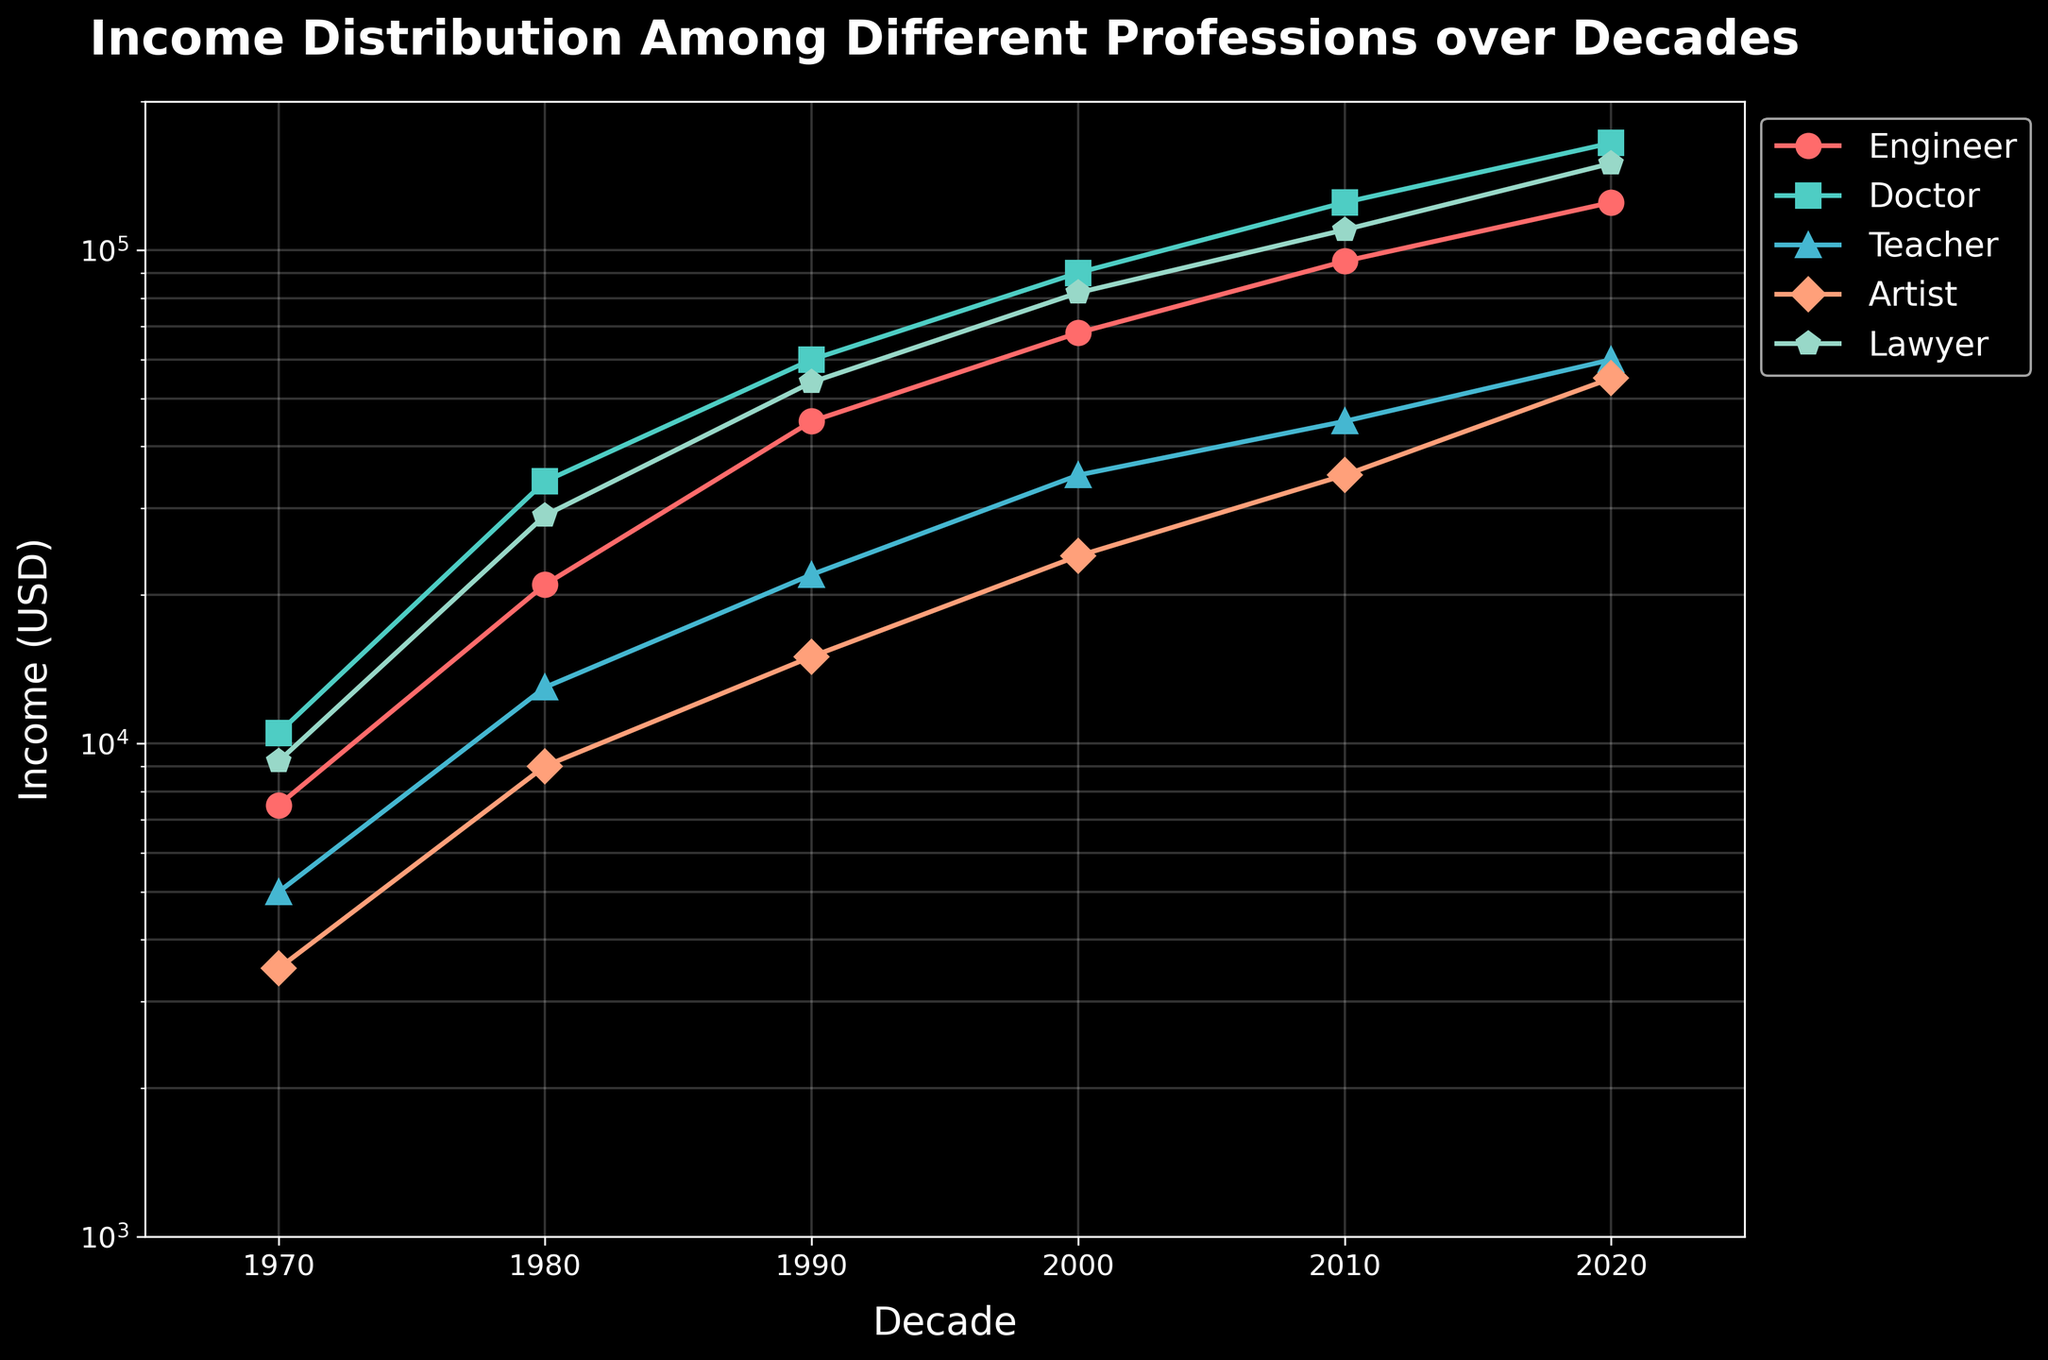What's the title of the plot? The title is usually prominently displayed at the top of the figure. Here, the title is in bold font and large size. It reads "Income Distribution Among Different Professions over Decades"
Answer: Income Distribution Among Different Professions over Decades What is the income range covered on the y-axis? The y-axis values are marked on a logarithmic scale, starting from 1000 to 200000. You can determine this range by looking at the minimum and maximum labeled values on the y-axis.
Answer: 1000 to 200000 Which profession had the highest income in 2020? By locating the data points for 2020 on the x-axis and observing the corresponding y-values for the different professions, you'll see that the Doctor profession has the highest point.
Answer: Doctor How does the income of Engineers change from 1970 to 2020? By following the line representing Engineers (marked with specific color and symbol), observe its upward trend from 7500 in 1970 to 125000 in 2020. This shows a consistent increase over the decades.
Answer: Increases Which decade experienced the most significant income increase for Lawyers? By examining the line for Lawyers, we notice the steepest portion between 1970 (9200) and 1980 (29000), indicating the largest decade-over-decade increase.
Answer: 1970 to 1980 What is the profession with the lowest income in 1970, and what was it? By identifying the lowest data point on the y-axis for the year 1970, we see that Artists had the lowest income, and the value was 3500.
Answer: Artist, 3500 Compare the income growth of Doctors and Teachers from 2000 to 2020. First, find the values for these professions in 2000 and 2020. Doctors go from 90000 to 165000 (a 75000 increase), while Teachers go from 35000 to 60000 (a 25000 increase). Doctors had a more substantial growth.
Answer: Doctors had higher growth 